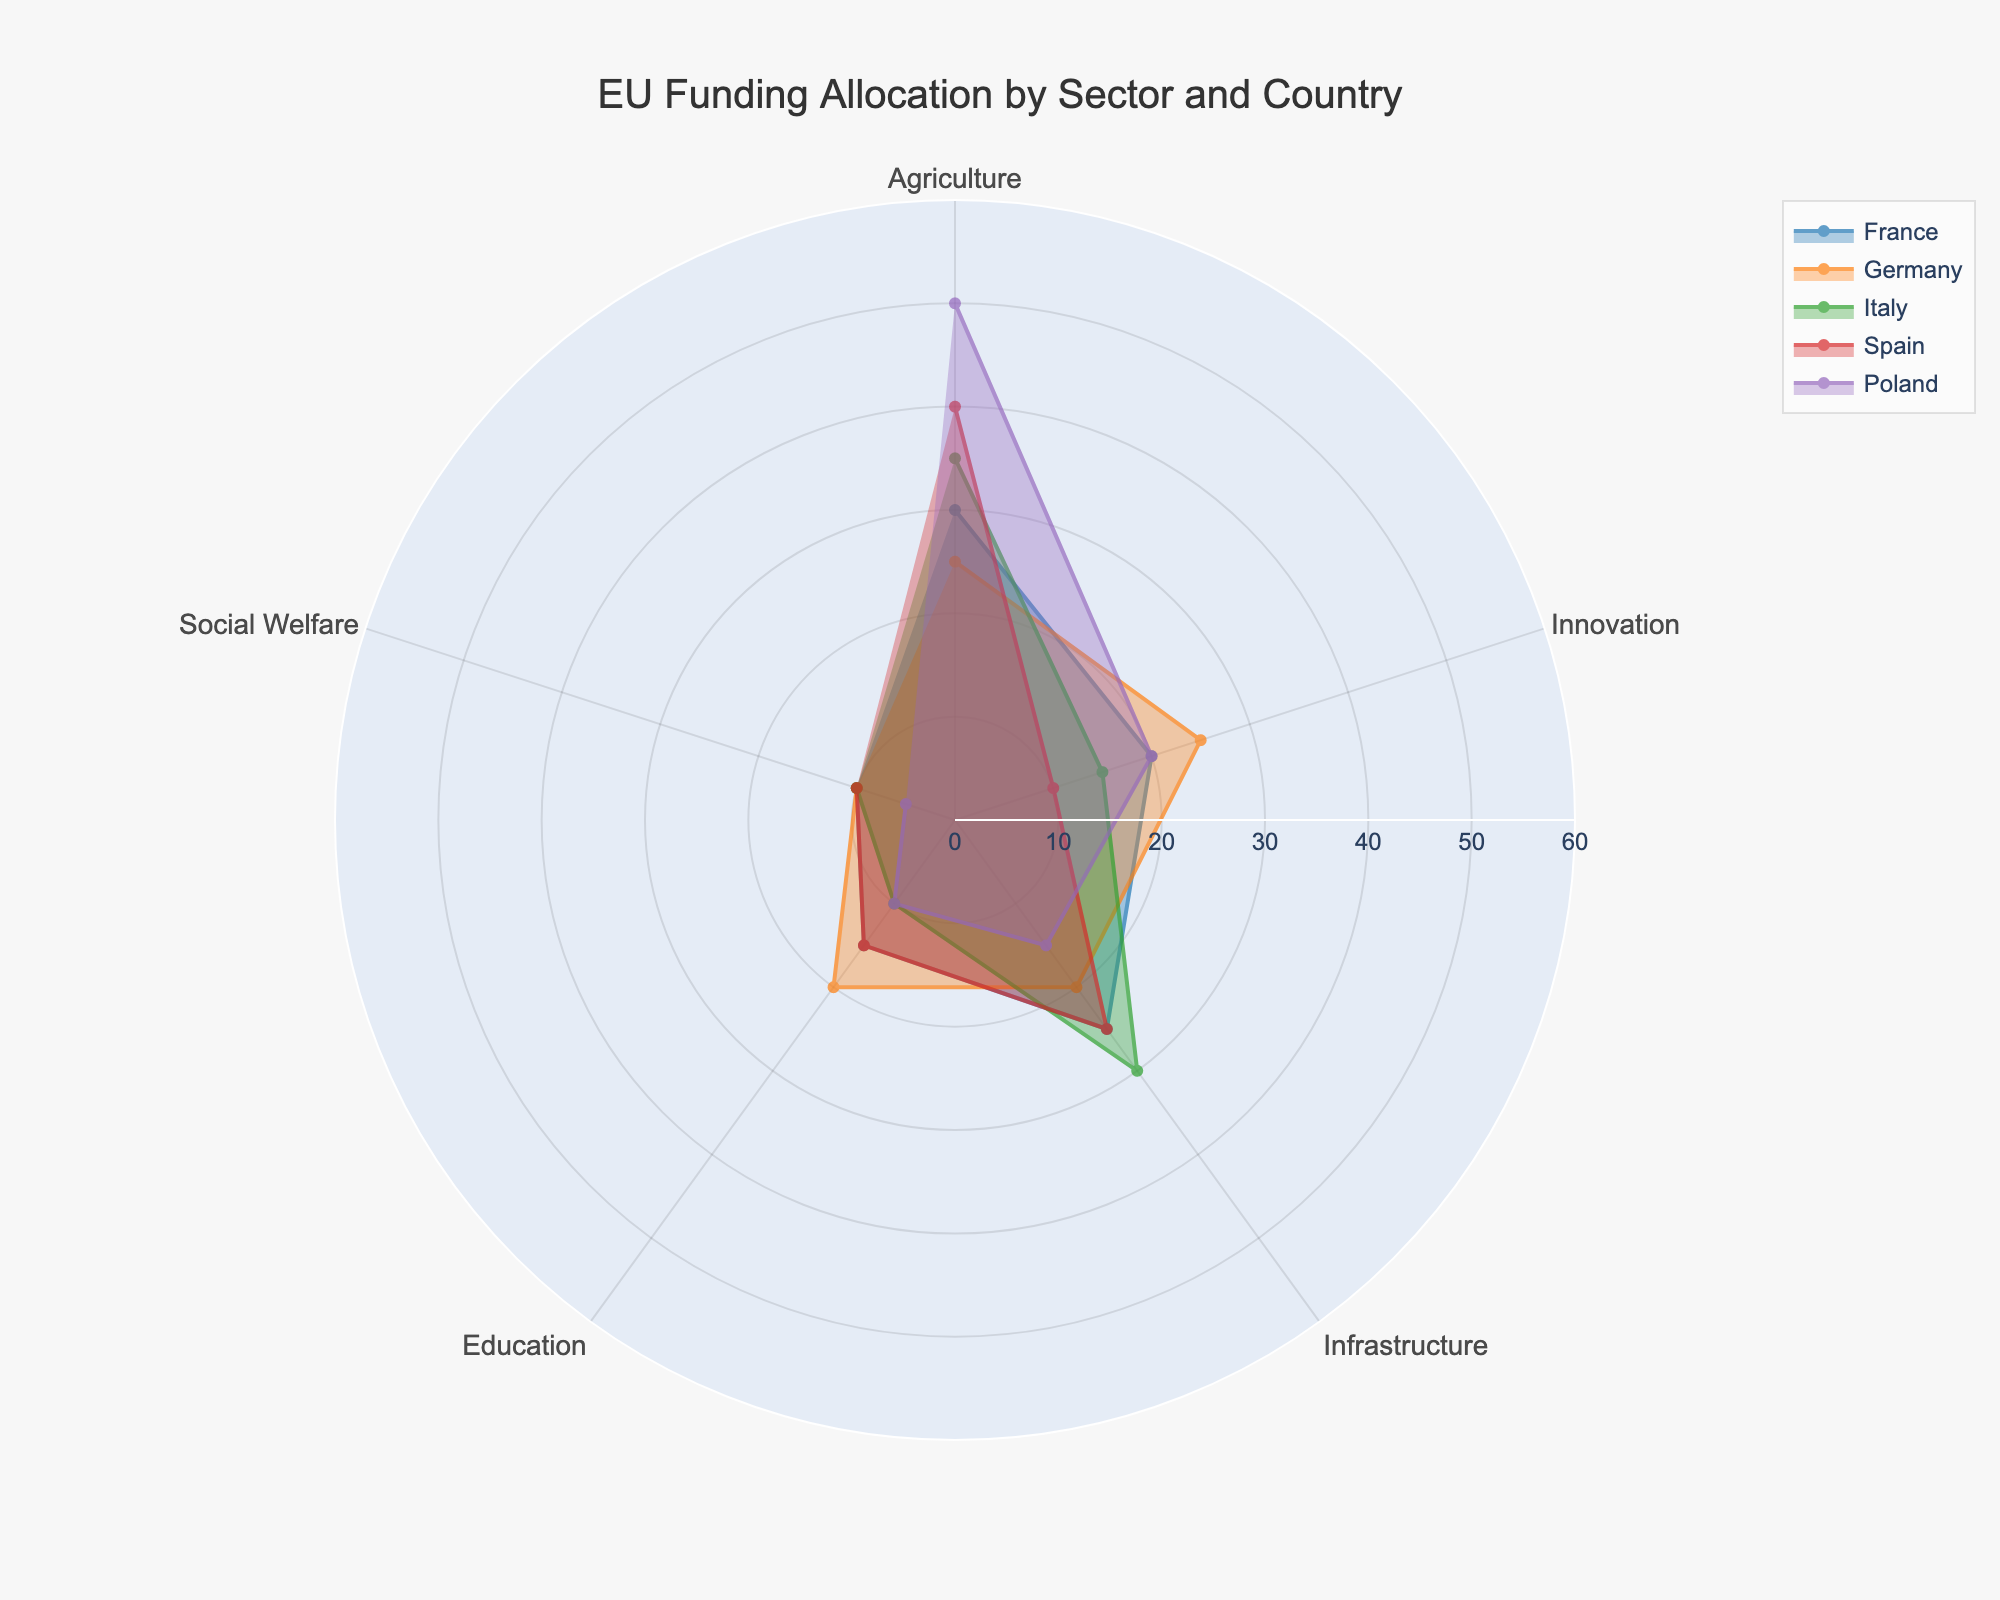What is the title of the radar chart? The title of the radar chart is displayed at the top of the figure. It summarizes the visual information being presented.
Answer: EU Funding Allocation by Sector and Country How many sectors are represented in the radar chart? Each point on the radar chart represents a different sector. By counting these points, we find the number of sectors.
Answer: 5 Which country allocates the highest percentage to Agriculture? Look at the sectors represented by each country's polygon in the radar chart and compare the values for Agriculture. The country with the highest point in the Agriculture section is the answer.
Answer: Poland What is the percentage difference in Innovation funding between France and Italy? Find the values for Innovation funding for both France (20%) and Italy (15%) on the radar chart. Subtract the smaller value from the larger one to get the difference.
Answer: 5% Which countries have the same percentage allocation for Social Welfare? Observe the points representing Social Welfare for each country on the radar chart. Identify the countries with the same points on this sector.
Answer: France, Germany, Italy, Spain Which country has the lowest allocation across all sectors? For each country, find the sum of all sector allocations. The country with the smallest sum has the lowest allocation overall.
Answer: Poland How does Germany's allocation to Infrastructure compare to Spain's? Locate Germany's and Spain's values for Infrastructure on the radar chart. Compare these values to determine which is higher.
Answer: They are equal What is the average percentage allocated to Education among all countries? Sum the values for Education for all countries (France, Germany, Italy, Spain, Poland) and divide by the number of countries (5). (15 + 20 + 10 + 15 + 10) / 5 = 14
Answer: 14% Which sector has the widest range of funding allocation across the countries? Calculate the range for each sector by finding the difference between the maximum and minimum values for each sector. The sector with the largest range is the one with the widest range of funding allocation.
Answer: Agriculture (50 - 25 = 25) Does any country allocate more than 40% funding to any sector? Examine the extremities of the polygons in the radar chart to check if any point extends beyond the 40% mark.
Answer: Yes, Poland in Agriculture 